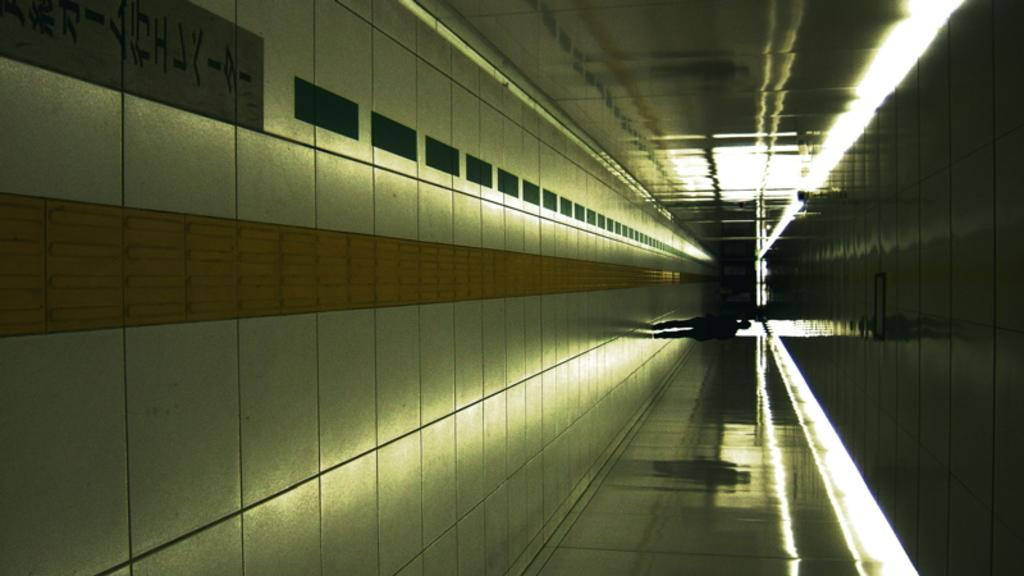What is the main subject of the image? The main subject of the image is a person walking. Where is the person walking? The person is walking on a walkway. What is located in the top left corner of the image? There is a board in the top left corner of the image. What objects resemble lights on the right side of the image? There are objects that resemble lights on the right side of the image. Can you tell me how many tails are visible on the person walking in the image? There are no tails visible on the person walking in the image, as humans do not have tails. What type of vase can be seen on the walkway in the image? There is no vase present on the walkway in the image. 